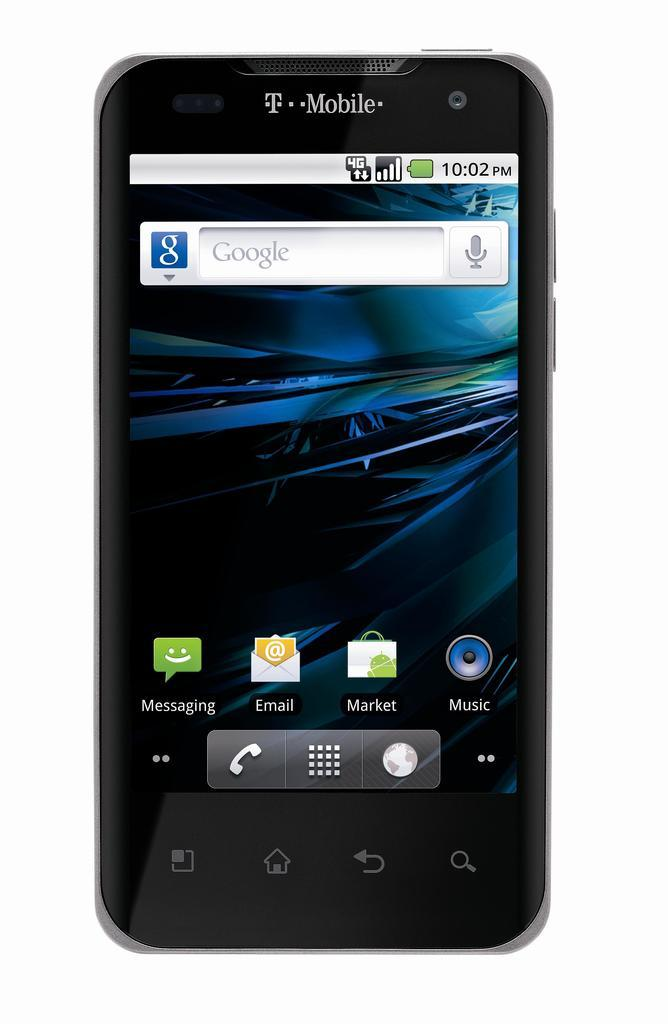<image>
Present a compact description of the photo's key features. the front of a cell phone with the t mobile carrier brand on the top of the device. 